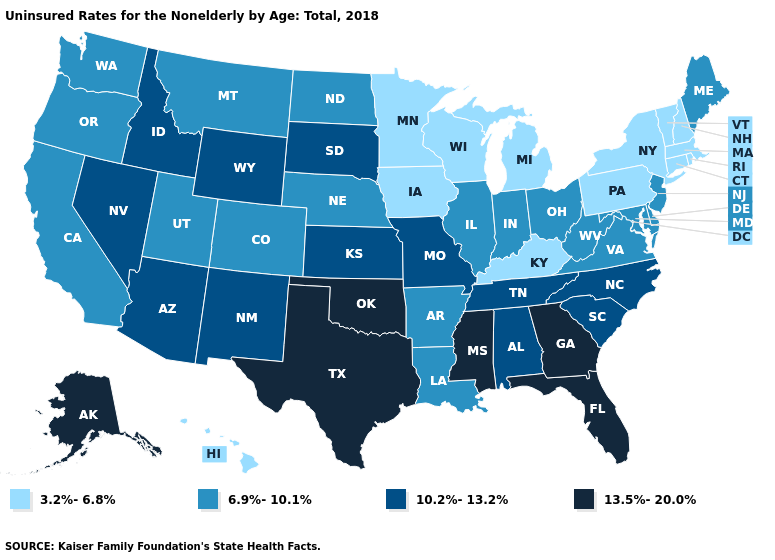What is the lowest value in the USA?
Short answer required. 3.2%-6.8%. Does Montana have a lower value than Arkansas?
Short answer required. No. Name the states that have a value in the range 3.2%-6.8%?
Give a very brief answer. Connecticut, Hawaii, Iowa, Kentucky, Massachusetts, Michigan, Minnesota, New Hampshire, New York, Pennsylvania, Rhode Island, Vermont, Wisconsin. Name the states that have a value in the range 13.5%-20.0%?
Quick response, please. Alaska, Florida, Georgia, Mississippi, Oklahoma, Texas. What is the highest value in the MidWest ?
Write a very short answer. 10.2%-13.2%. Name the states that have a value in the range 3.2%-6.8%?
Keep it brief. Connecticut, Hawaii, Iowa, Kentucky, Massachusetts, Michigan, Minnesota, New Hampshire, New York, Pennsylvania, Rhode Island, Vermont, Wisconsin. Name the states that have a value in the range 13.5%-20.0%?
Be succinct. Alaska, Florida, Georgia, Mississippi, Oklahoma, Texas. What is the lowest value in the South?
Answer briefly. 3.2%-6.8%. Is the legend a continuous bar?
Quick response, please. No. Does Arkansas have a higher value than Michigan?
Write a very short answer. Yes. What is the value of Pennsylvania?
Be succinct. 3.2%-6.8%. How many symbols are there in the legend?
Concise answer only. 4. Name the states that have a value in the range 10.2%-13.2%?
Concise answer only. Alabama, Arizona, Idaho, Kansas, Missouri, Nevada, New Mexico, North Carolina, South Carolina, South Dakota, Tennessee, Wyoming. Which states have the lowest value in the West?
Concise answer only. Hawaii. What is the lowest value in the USA?
Concise answer only. 3.2%-6.8%. 